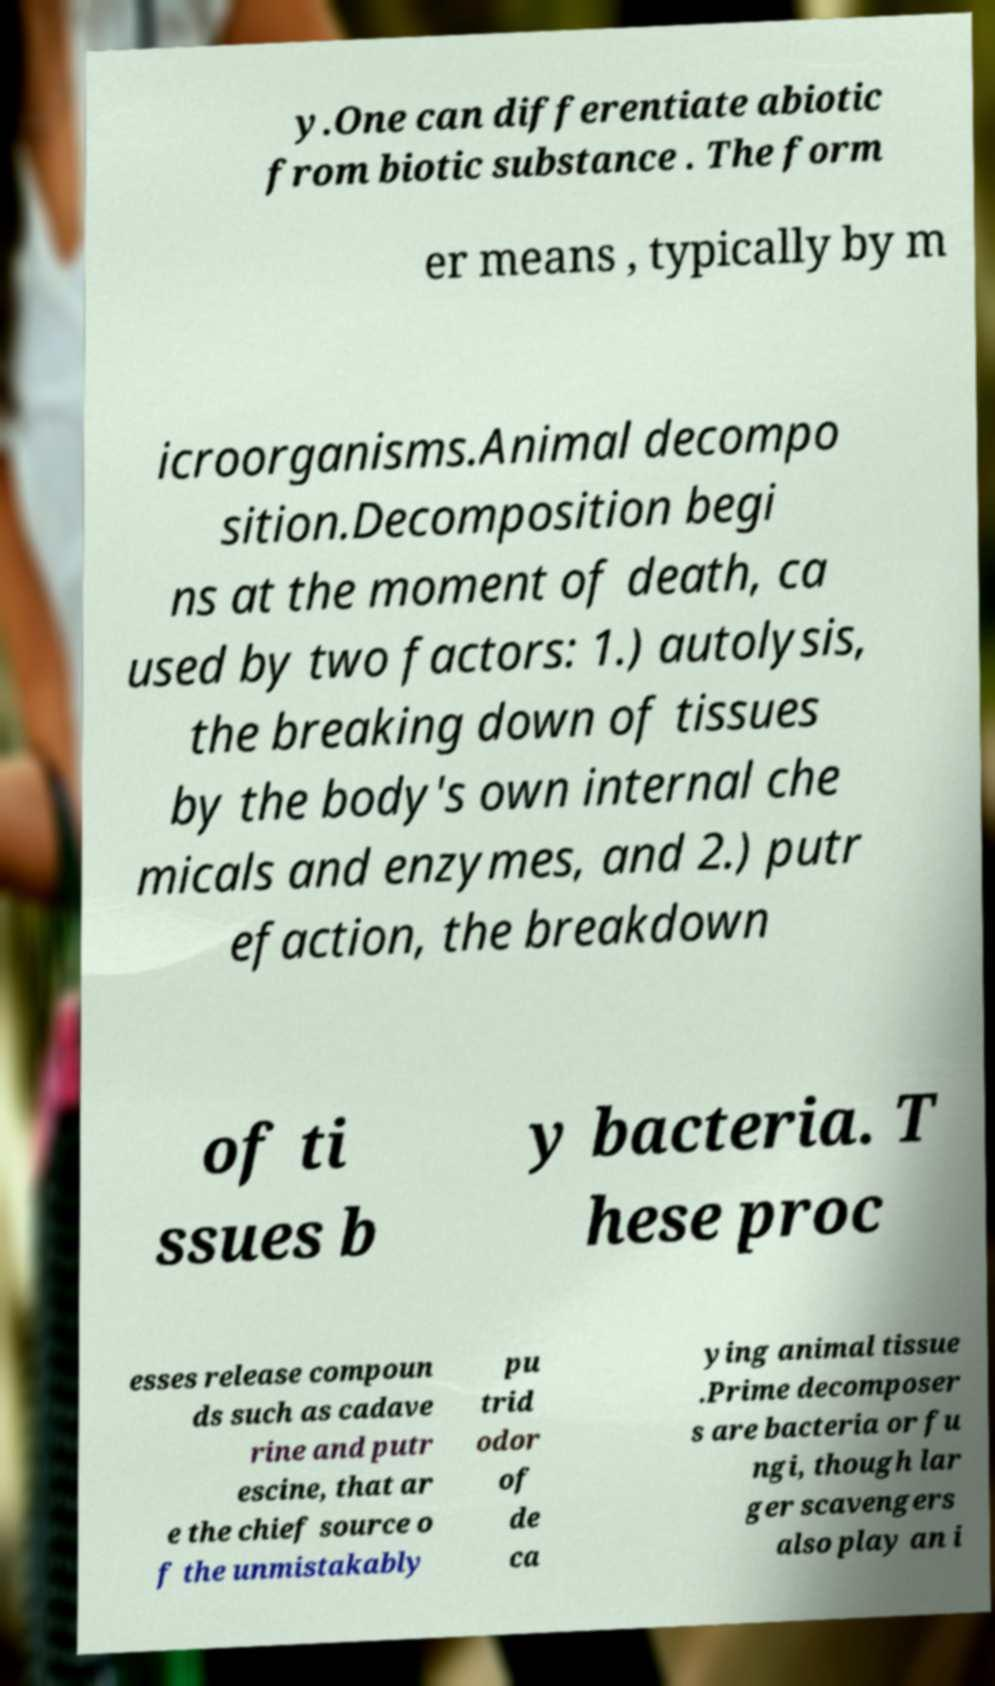Please read and relay the text visible in this image. What does it say? y.One can differentiate abiotic from biotic substance . The form er means , typically by m icroorganisms.Animal decompo sition.Decomposition begi ns at the moment of death, ca used by two factors: 1.) autolysis, the breaking down of tissues by the body's own internal che micals and enzymes, and 2.) putr efaction, the breakdown of ti ssues b y bacteria. T hese proc esses release compoun ds such as cadave rine and putr escine, that ar e the chief source o f the unmistakably pu trid odor of de ca ying animal tissue .Prime decomposer s are bacteria or fu ngi, though lar ger scavengers also play an i 